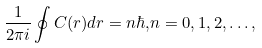Convert formula to latex. <formula><loc_0><loc_0><loc_500><loc_500>\frac { 1 } { 2 \pi i } \oint { C ( r ) d r = n \hbar { , } n = 0 , 1 , 2 , \dots , }</formula> 